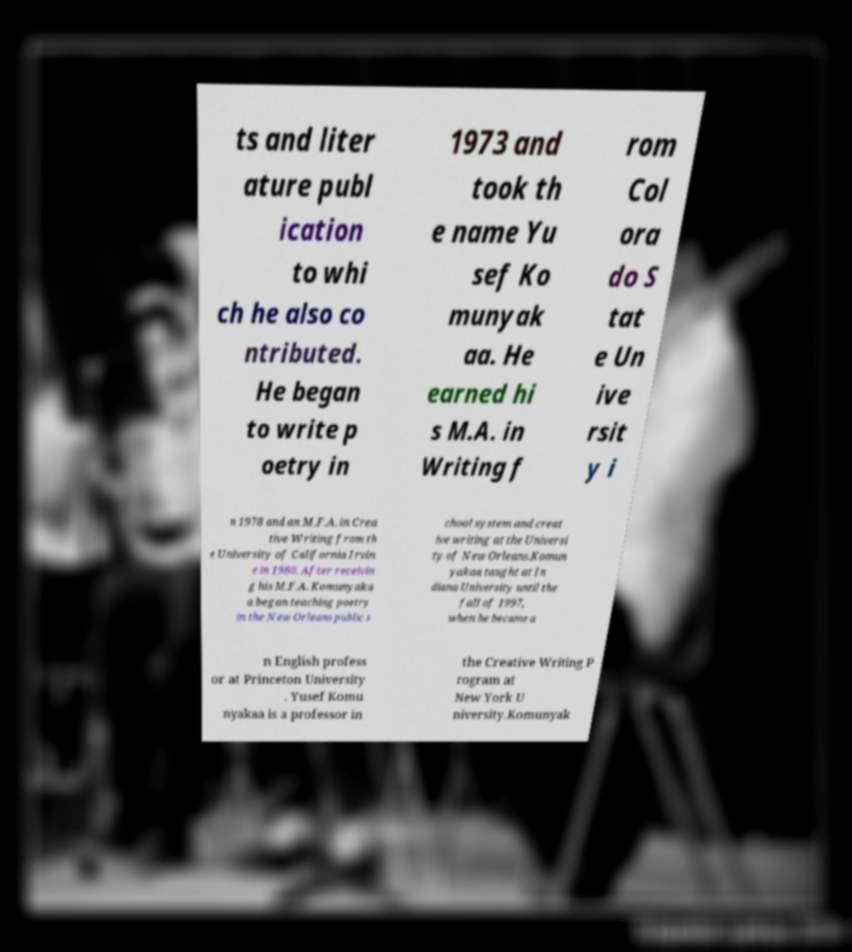Can you read and provide the text displayed in the image?This photo seems to have some interesting text. Can you extract and type it out for me? ts and liter ature publ ication to whi ch he also co ntributed. He began to write p oetry in 1973 and took th e name Yu sef Ko munyak aa. He earned hi s M.A. in Writing f rom Col ora do S tat e Un ive rsit y i n 1978 and an M.F.A. in Crea tive Writing from th e University of California Irvin e in 1980. After receivin g his M.F.A. Komunyaka a began teaching poetry in the New Orleans public s chool system and creat ive writing at the Universi ty of New Orleans.Komun yakaa taught at In diana University until the fall of 1997, when he became a n English profess or at Princeton University . Yusef Komu nyakaa is a professor in the Creative Writing P rogram at New York U niversity.Komunyak 